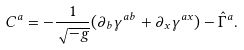<formula> <loc_0><loc_0><loc_500><loc_500>C ^ { a } = - \frac { 1 } { \sqrt { - g } } ( \partial _ { b } \gamma ^ { a b } + \partial _ { x } \gamma ^ { a x } ) - \hat { \Gamma } ^ { a } .</formula> 